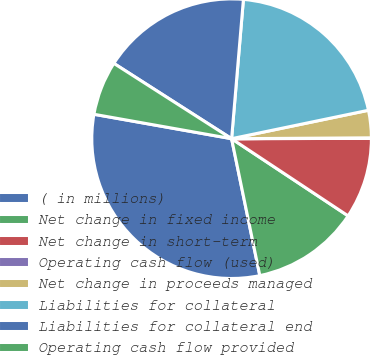Convert chart. <chart><loc_0><loc_0><loc_500><loc_500><pie_chart><fcel>( in millions)<fcel>Net change in fixed income<fcel>Net change in short-term<fcel>Operating cash flow (used)<fcel>Net change in proceeds managed<fcel>Liabilities for collateral<fcel>Liabilities for collateral end<fcel>Operating cash flow provided<nl><fcel>31.03%<fcel>12.45%<fcel>9.35%<fcel>0.06%<fcel>3.16%<fcel>20.39%<fcel>17.29%<fcel>6.26%<nl></chart> 